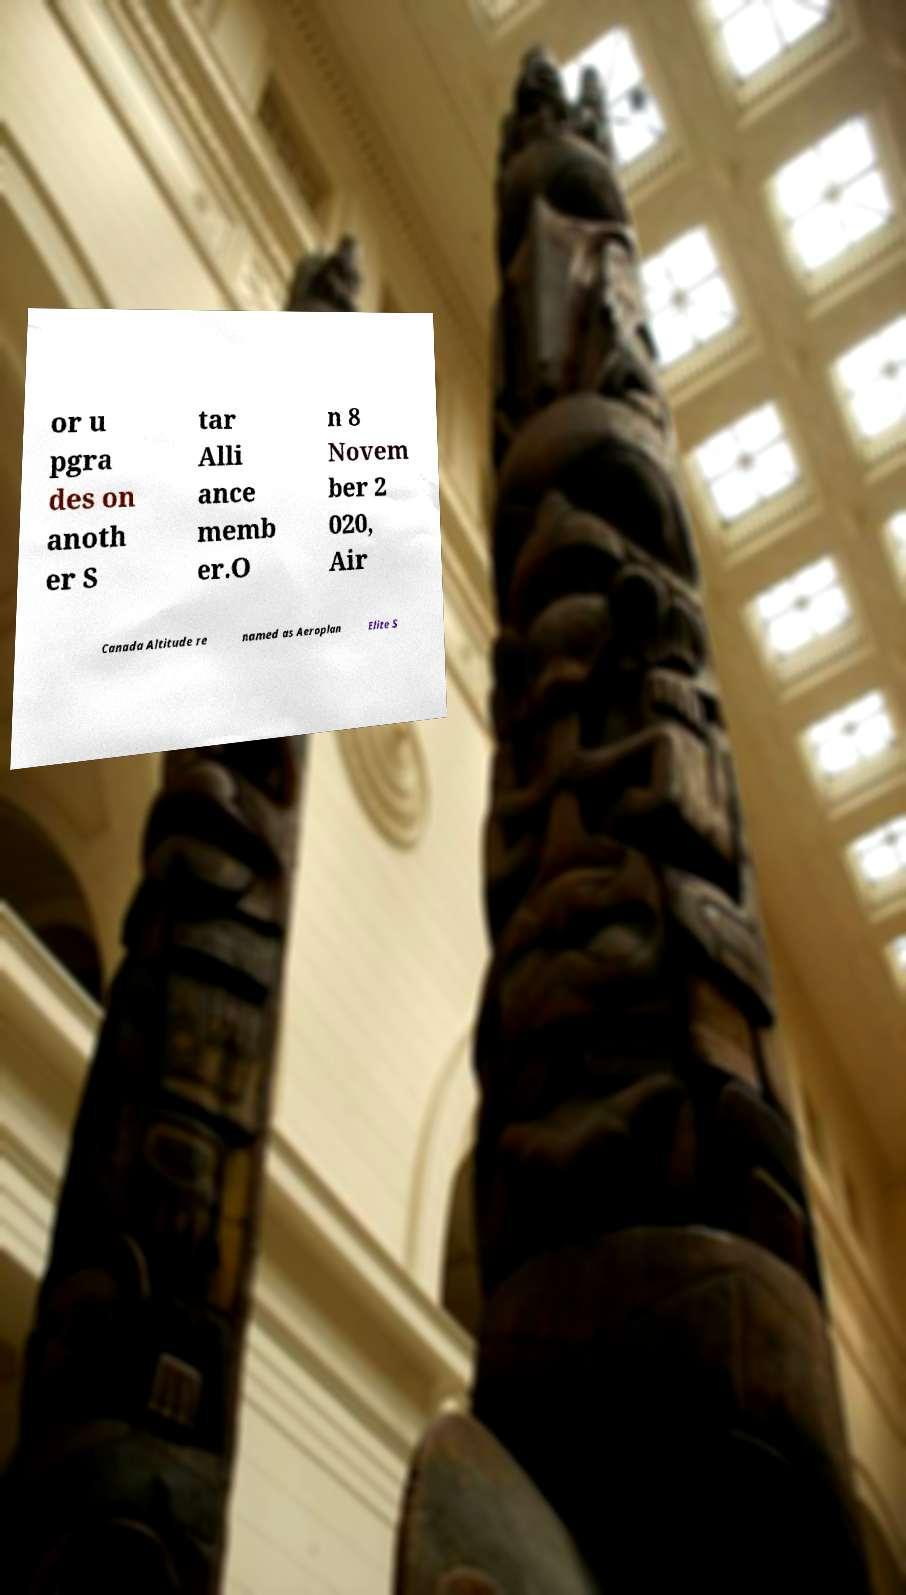What messages or text are displayed in this image? I need them in a readable, typed format. or u pgra des on anoth er S tar Alli ance memb er.O n 8 Novem ber 2 020, Air Canada Altitude re named as Aeroplan Elite S 